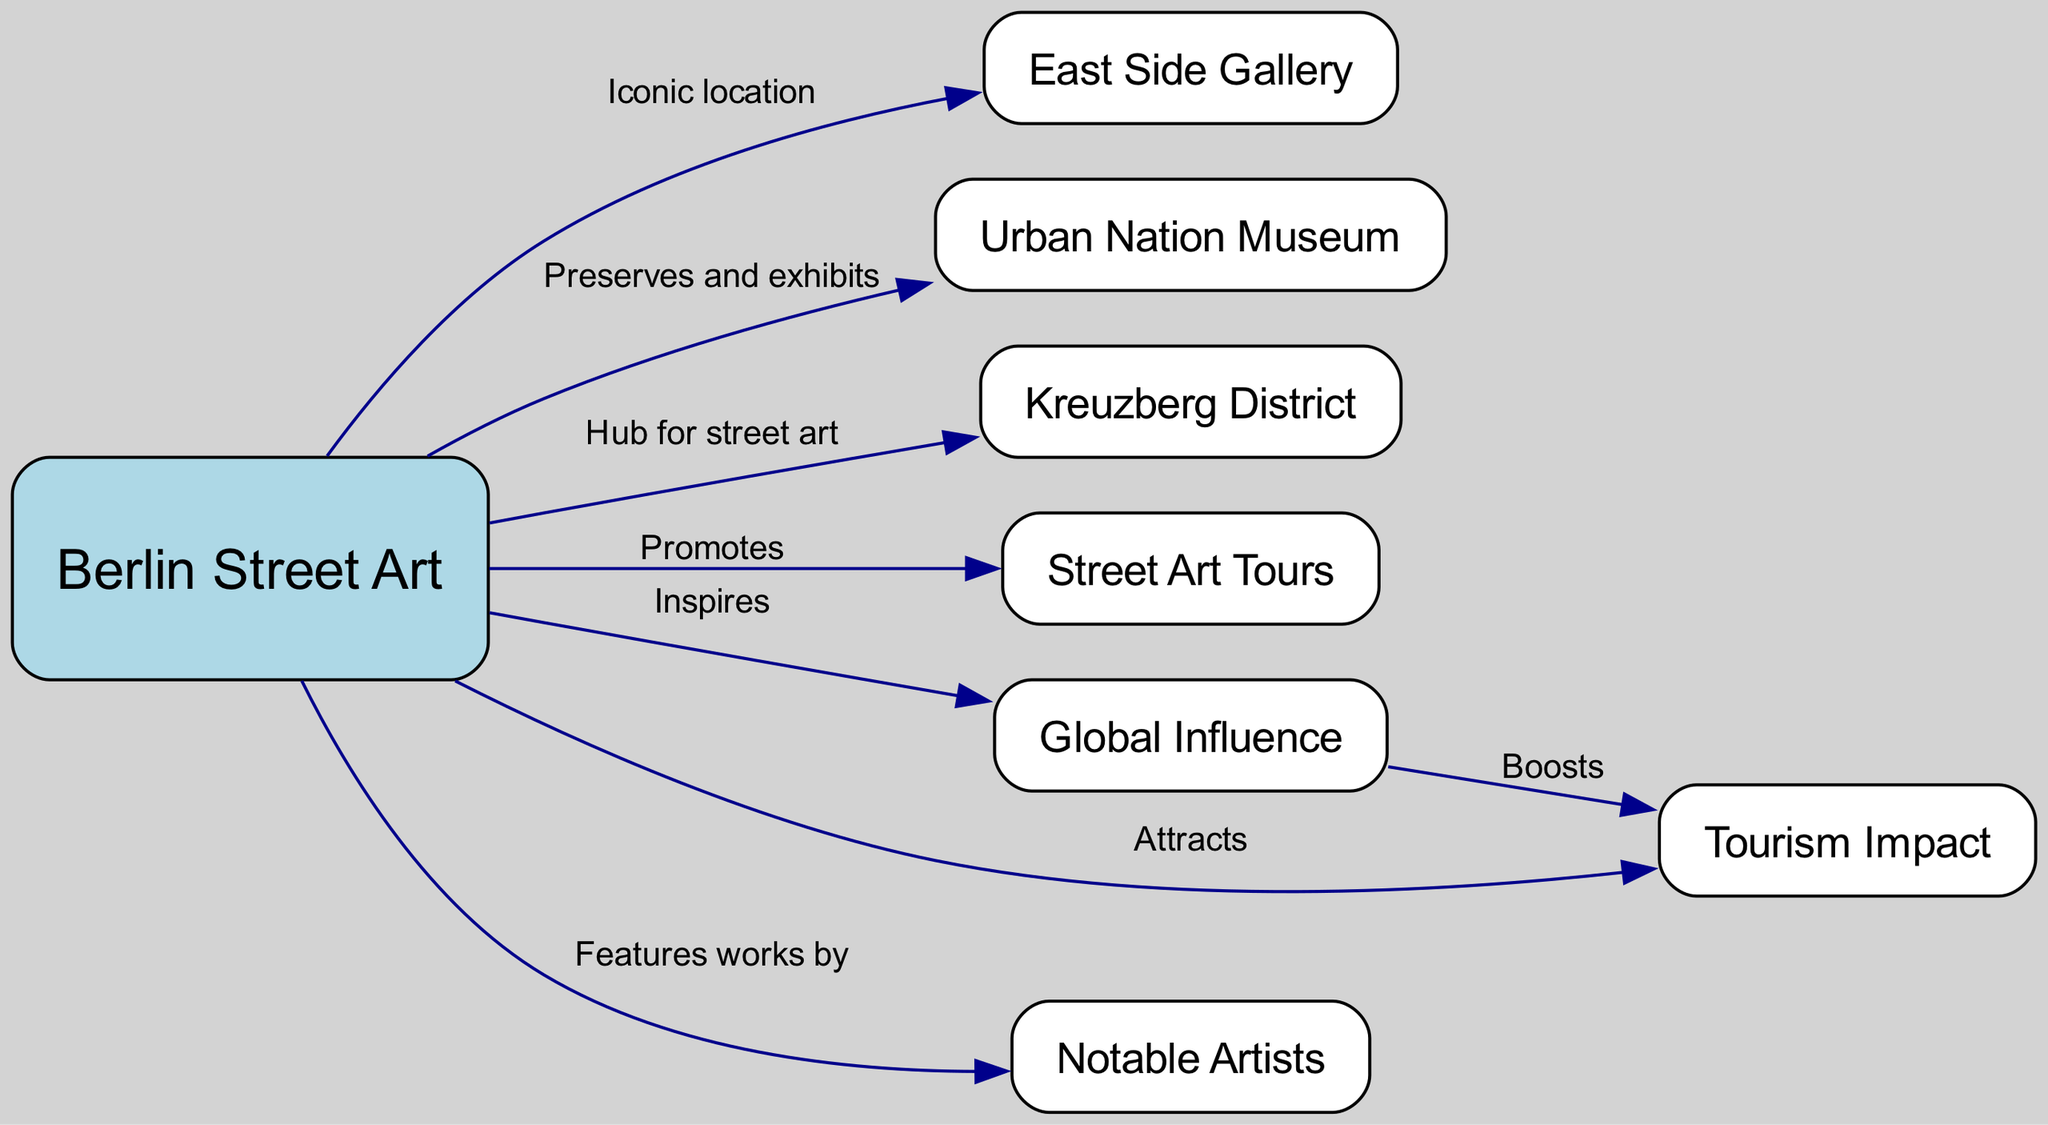What is the iconic location associated with Berlin Street Art? Berlin Street Art is connected to the East Side Gallery, which is labeled as an iconic location in the diagram.
Answer: East Side Gallery How many nodes are present in the diagram? The diagram contains a total of 8 nodes, which represent various aspects related to Berlin Street Art.
Answer: 8 What does Berlin Street Art do to promote street art tourism? Berlin Street Art promotes street art tourism through organized street art tours, as indicated in the diagram.
Answer: Street Art Tours Which district is identified as a hub for street art? The Kreuzberg District is specified in the diagram as a central hub for street art, highlighting its significance in the context of Berlin.
Answer: Kreuzberg District How does global influence affect tourism related to Berlin's street art? The diagram shows that global influence boosts tourism, indicating a synergy between the two aspects where one enhances the other.
Answer: Boosts Who are featured as artists in Berlin Street Art? The diagram notes that notable artists are featured within the context of Berlin Street Art, acknowledging their contributions to the scene.
Answer: Notable Artists What role does Urban Nation Museum play in Berlin Street Art? Urban Nation Museum is described in the diagram as a place that preserves and exhibits Berlin Street Art, reflecting its commitment to this art form.
Answer: Preserves and exhibits List one element that attracts tourism to Berlin Street Art. The diagram indicates that Berlin Street Art attracts tourism, showcasing its appeal and cultural significance for visitors.
Answer: Attracts 